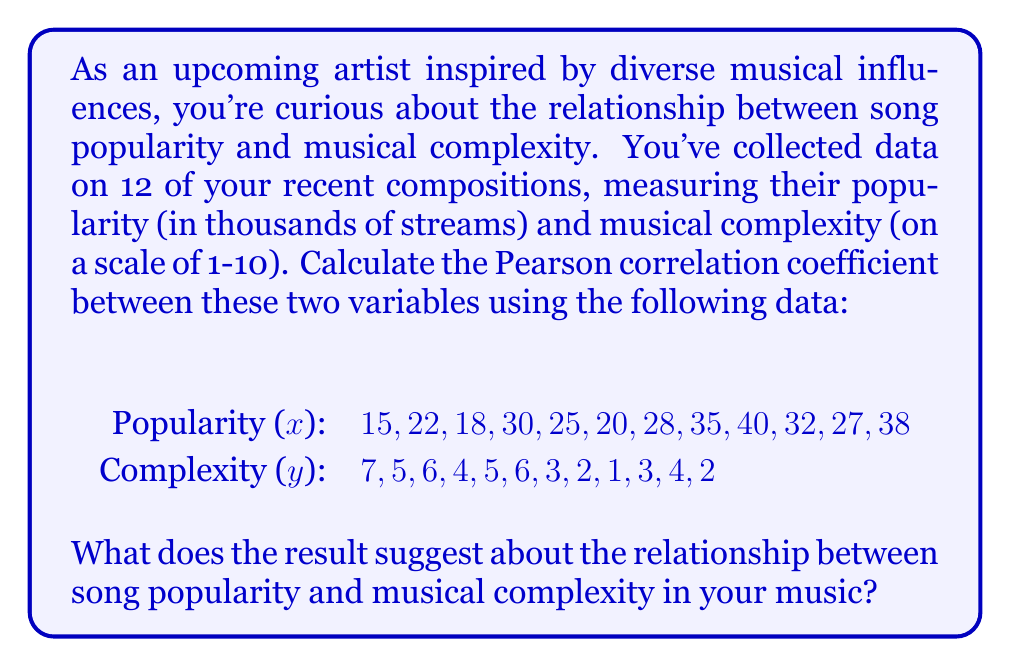Solve this math problem. To calculate the Pearson correlation coefficient (r), we'll use the formula:

$$ r = \frac{\sum_{i=1}^{n} (x_i - \bar{x})(y_i - \bar{y})}{\sqrt{\sum_{i=1}^{n} (x_i - \bar{x})^2 \sum_{i=1}^{n} (y_i - \bar{y})^2}} $$

Where:
$x_i$ and $y_i$ are individual values
$\bar{x}$ and $\bar{y}$ are the means of x and y respectively
n is the number of pairs

Steps:
1. Calculate the means:
   $\bar{x} = \frac{330}{12} = 27.5$
   $\bar{y} = \frac{48}{12} = 4$

2. Calculate $(x_i - \bar{x})$, $(y_i - \bar{y})$, $(x_i - \bar{x})^2$, $(y_i - \bar{y})^2$, and $(x_i - \bar{x})(y_i - \bar{y})$ for each pair.

3. Sum up the results:
   $\sum (x_i - \bar{x})(y_i - \bar{y}) = -322.5$
   $\sum (x_i - \bar{x})^2 = 1118.75$
   $\sum (y_i - \bar{y})^2 = 62$

4. Apply the formula:
   $$ r = \frac{-322.5}{\sqrt{1118.75 \times 62}} = \frac{-322.5}{\sqrt{69362.5}} = \frac{-322.5}{263.37} \approx -0.9974 $$

The correlation coefficient is approximately -0.9974, which indicates a very strong negative correlation between song popularity and musical complexity in your compositions.
Answer: The Pearson correlation coefficient is approximately -0.9974, suggesting a very strong negative correlation between song popularity and musical complexity in your music. This means that as the musical complexity increases, the popularity of your songs tends to decrease, and vice versa. As an upcoming artist, this information could be valuable in understanding your audience's preferences and potentially guiding your future compositions. 